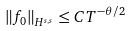Convert formula to latex. <formula><loc_0><loc_0><loc_500><loc_500>\left \| f _ { 0 } \right \| _ { H ^ { s , s } } \leq C T ^ { - \theta / 2 }</formula> 